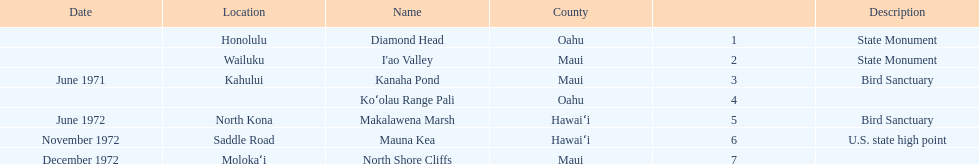Other than mauna kea, name a place in hawaii. Makalawena Marsh. 